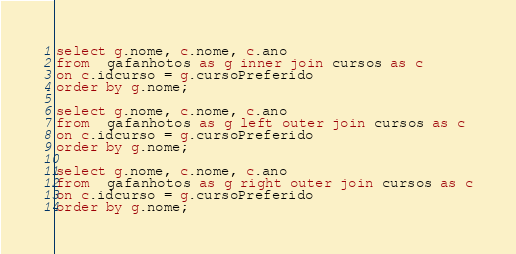Convert code to text. <code><loc_0><loc_0><loc_500><loc_500><_SQL_>select g.nome, c.nome, c.ano
from  gafanhotos as g inner join cursos as c
on c.idcurso = g.cursoPreferido
order by g.nome;

select g.nome, c.nome, c.ano
from  gafanhotos as g left outer join cursos as c
on c.idcurso = g.cursoPreferido
order by g.nome;

select g.nome, c.nome, c.ano
from  gafanhotos as g right outer join cursos as c
on c.idcurso = g.cursoPreferido
order by g.nome;</code> 